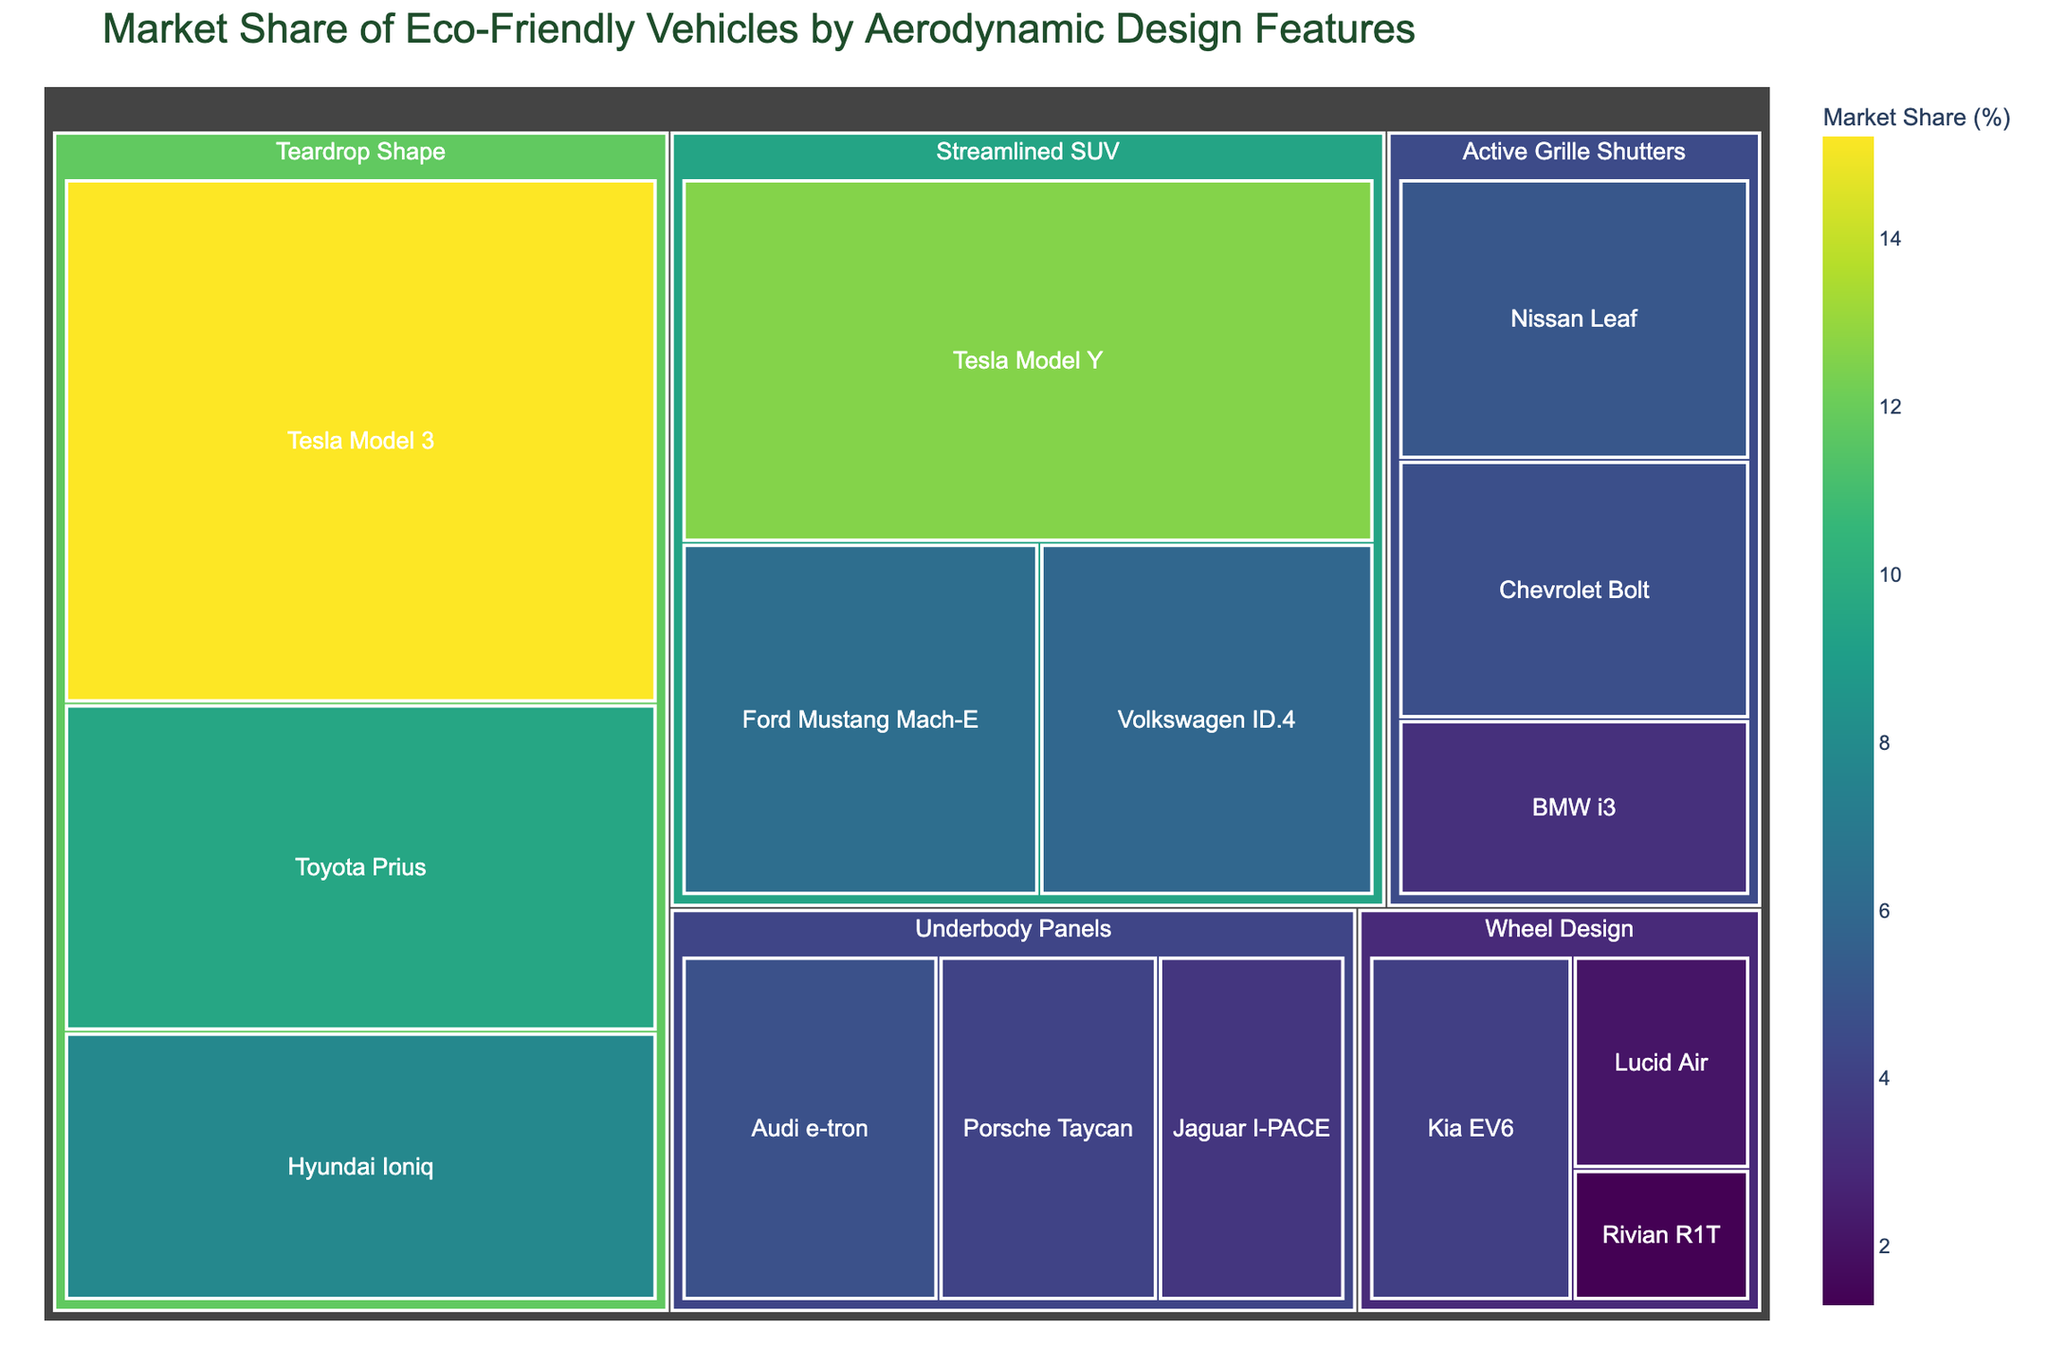what are the major categories representing aerodynamic design features? There are four major categories in the Treemap: Teardrop Shape, Streamlined SUV, Active Grille Shutters, and Underbody Panels, each representing different aerodynamic design features.
Answer: Teardrop Shape, Streamlined SUV, Active Grille Shutters, Underbody Panels what is the market share percentage of Tesla Model 3? The Treemap shows that the Tesla Model 3 has a market share value of 15.2%.
Answer: 15.2% which subcategory has the highest market share within the Streamlined SUV category? Within the Streamlined SUV category, Tesla Model Y has the highest market share with a value of 12.6%.
Answer: Tesla Model Y how does the market share of Hyundai Ioniq compare to Ford Mustang Mach-E? The market share of Hyundai Ioniq is higher than that of Ford Mustang Mach-E, with values of 7.8% and 6.3%, respectively.
Answer: Hyundai Ioniq is higher what is the combined market share of vehicles under the Active Grille Shutters category? The sum of the market shares for Chevrolet Bolt (4.7%), Nissan Leaf (5.1%), and BMW i3 (3.2%) in the Active Grille Shutters category is 4.7 + 5.1 + 3.2 = 13.0%.
Answer: 13.0% which vehicle has the lowest market share in the figure? The Rivian R1T has the lowest market share of all vehicles, with a value of 1.3%.
Answer: Rivian R1T what is the average market share of the vehicles categorized under the Teardrop Shape? The market share values for the vehicles under the Teardrop Shape category are 15.2 (Tesla Model 3), 7.8 (Hyundai Ioniq), and 9.5 (Toyota Prius). The average is (15.2 + 7.8 + 9.5) / 3 = 32.5 / 3 = 10.83%.
Answer: 10.83% which category shows the most variation in market share values? Comparing the spread of values within each category, the Teardrop Shape category has values ranging from 7.8% to 15.2%, the largest spread compared to others.
Answer: Teardrop Shape what is the total market share represented by the Wheel Design category? The sum of the market shares in the Wheel Design category which includes Kia EV6 (3.9%), Lucid Air (2.1%), and Rivian R1T (1.3%) is 3.9 + 2.1 + 1.3 = 7.3%.
Answer: 7.3% is there any vehicle brand that appears in more than one category? If so, which brand and categories? Tesla appears in both the Teardrop Shape category with Tesla Model 3 and the Streamlined SUV category with Tesla Model Y.
Answer: Tesla, Teardrop Shape and Streamlined SUV 